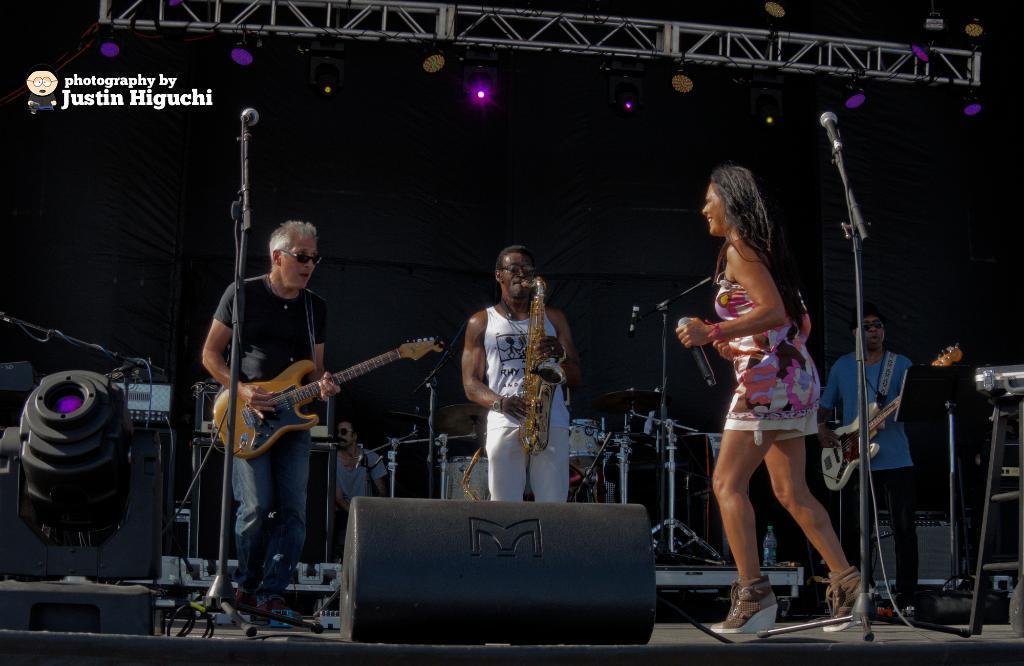Please provide a concise description of this image. In this picture we can see three men and a woman, this woman is holding a microphone, a man on the left side is playing a guitar, a man in the middle is playing a saxophone, a man on the right side is playing a guitar, in the background we can see another person, there are two microphones, and a music stand in the front, in the background there are some musical instruments, there is some text at the left top of the picture. 